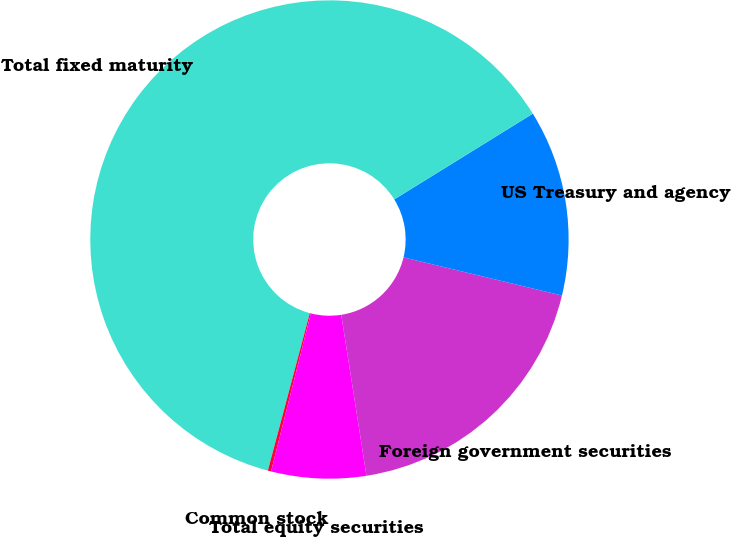Convert chart. <chart><loc_0><loc_0><loc_500><loc_500><pie_chart><fcel>Foreign government securities<fcel>US Treasury and agency<fcel>Total fixed maturity<fcel>Common stock<fcel>Total equity securities<nl><fcel>18.76%<fcel>12.58%<fcel>62.03%<fcel>0.22%<fcel>6.4%<nl></chart> 